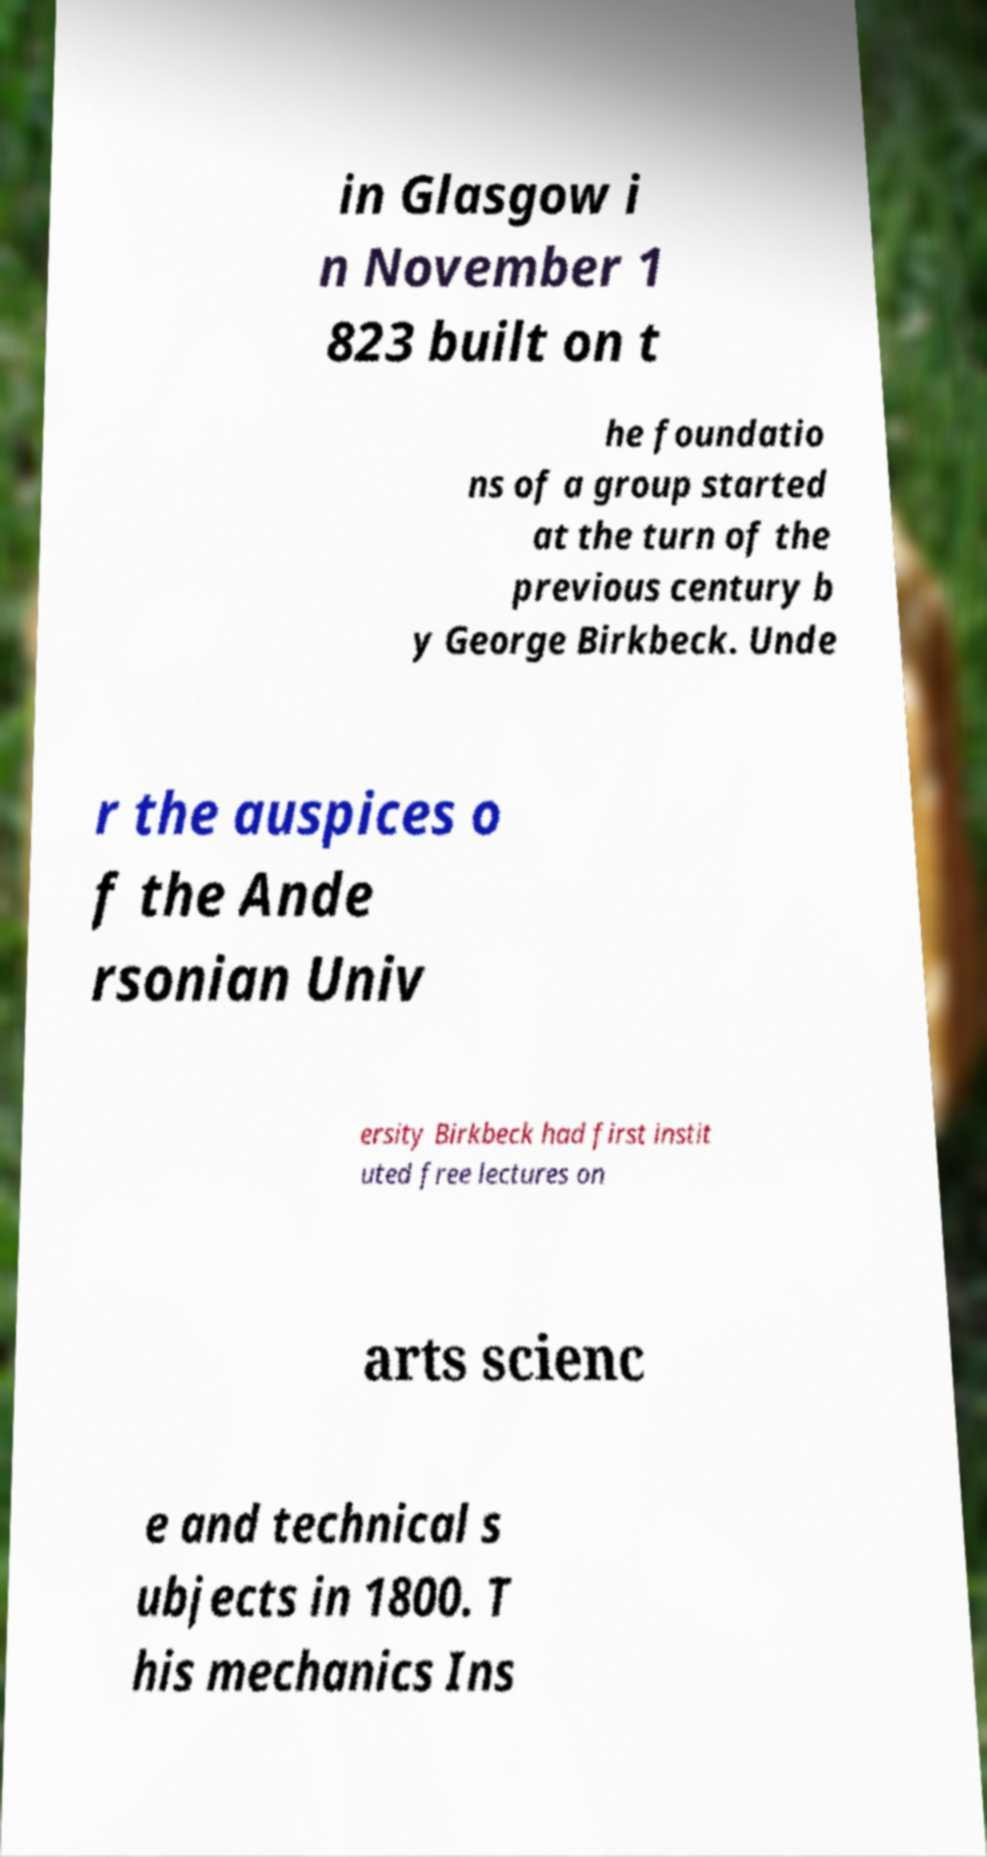Could you extract and type out the text from this image? in Glasgow i n November 1 823 built on t he foundatio ns of a group started at the turn of the previous century b y George Birkbeck. Unde r the auspices o f the Ande rsonian Univ ersity Birkbeck had first instit uted free lectures on arts scienc e and technical s ubjects in 1800. T his mechanics Ins 